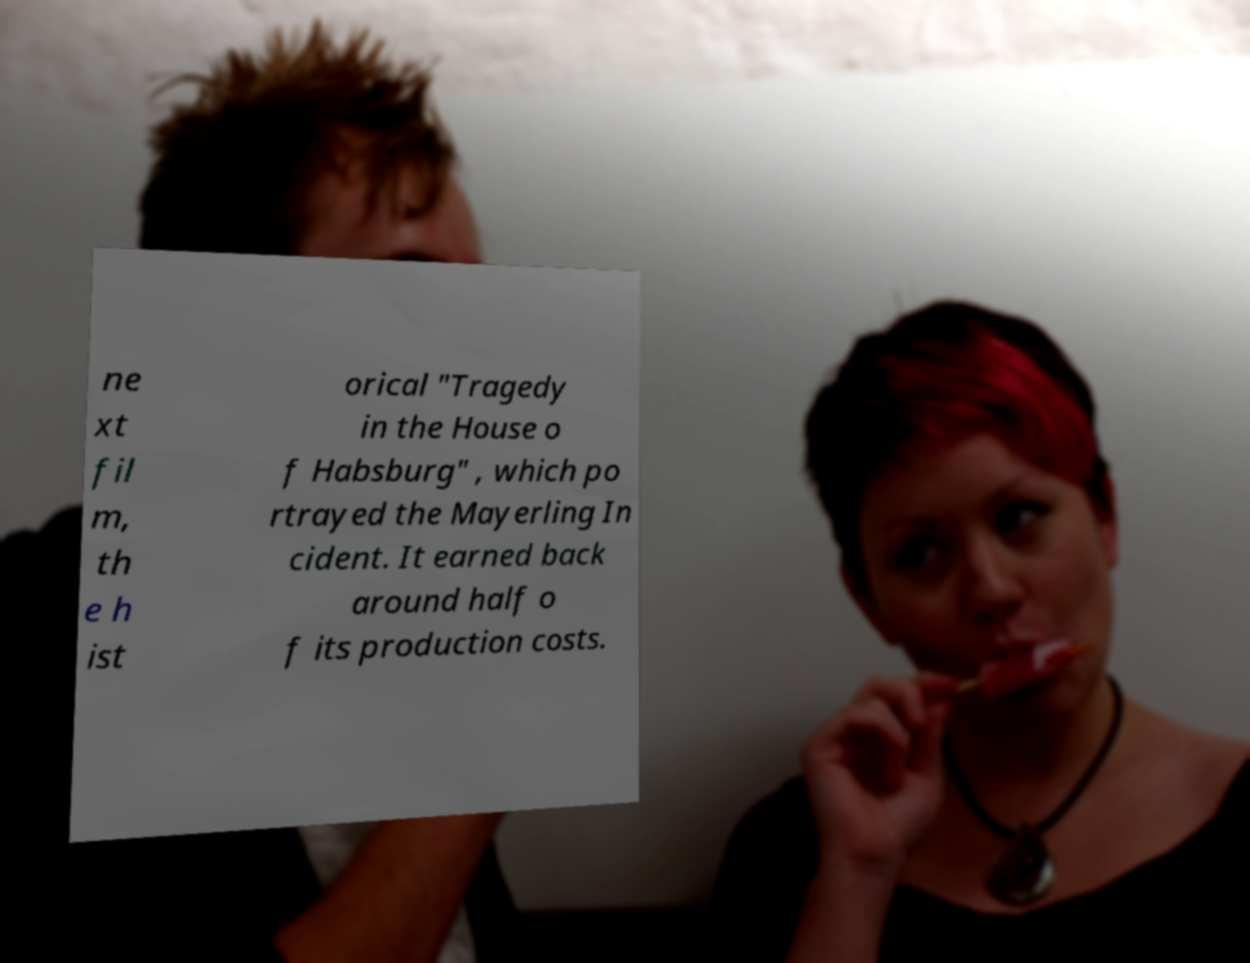Please read and relay the text visible in this image. What does it say? ne xt fil m, th e h ist orical "Tragedy in the House o f Habsburg" , which po rtrayed the Mayerling In cident. It earned back around half o f its production costs. 